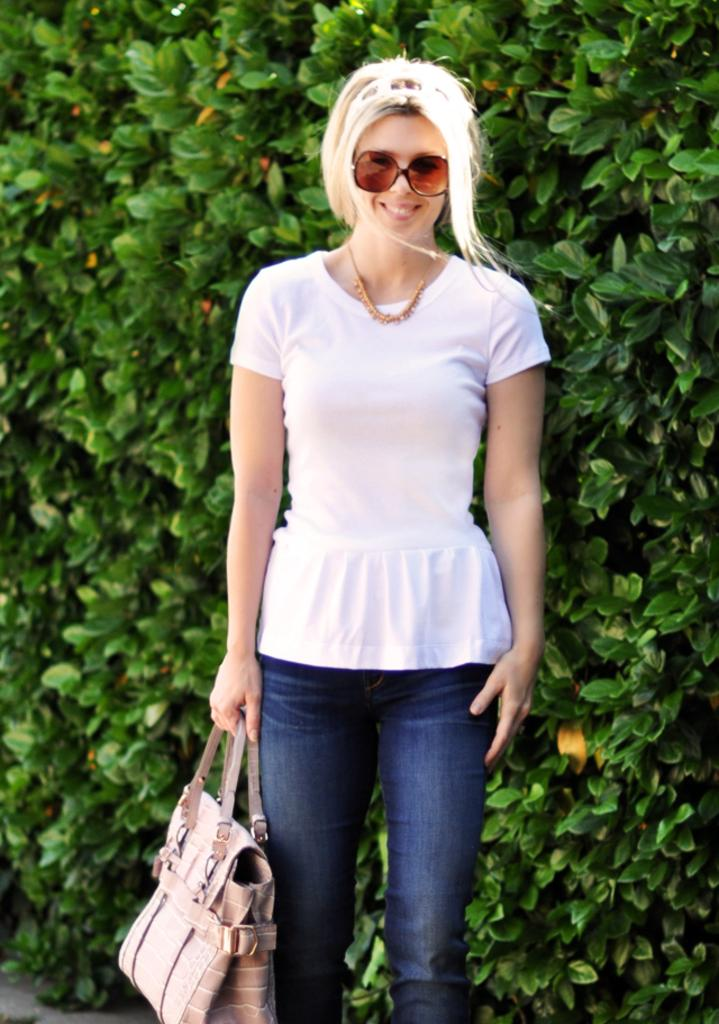Who is present in the image? There is a woman in the image. What is the woman wearing? The woman is wearing a white t-shirt and spectacles. What is the woman doing in the image? The woman is laughing and standing. What is the woman holding in the image? The woman is holding a handbag. What can be seen in the background of the image? There are plants in the background of the image. Can you see a pen being used by the woman in the image? There is no pen visible in the image. Is the woman riding a carriage in the image? There is no carriage present in the image. 